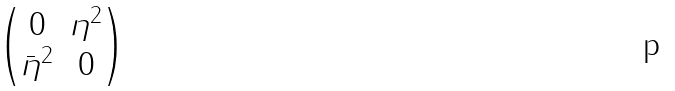Convert formula to latex. <formula><loc_0><loc_0><loc_500><loc_500>\begin{pmatrix} 0 & \eta ^ { 2 } \\ \bar { \eta } ^ { 2 } & 0 \end{pmatrix}</formula> 